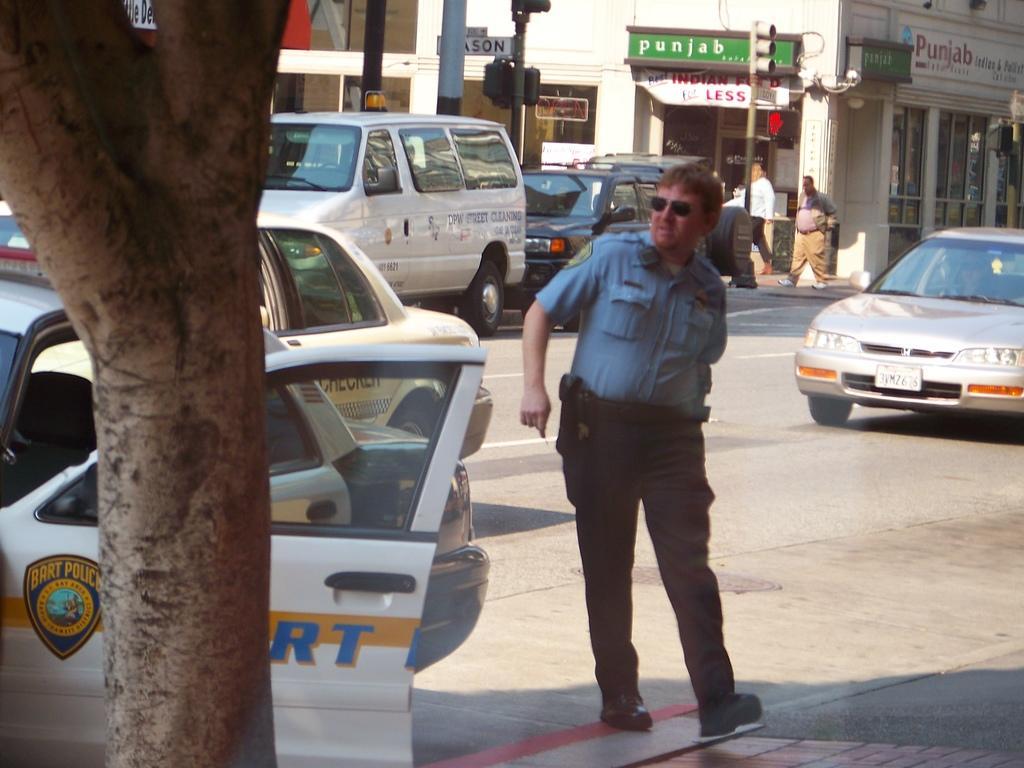In one or two sentences, can you explain what this image depicts? In this picture there is a man who is wearing google, shirt, trouser and shoes. On his stomach I can see the gun. Besides him I can see many cars on the road. In the background I can see two men who are walking on the street. Beside them I can see the buildings, street lights, traffic signals and other objects. In the top right corner I can see the board and CCTV camera. 